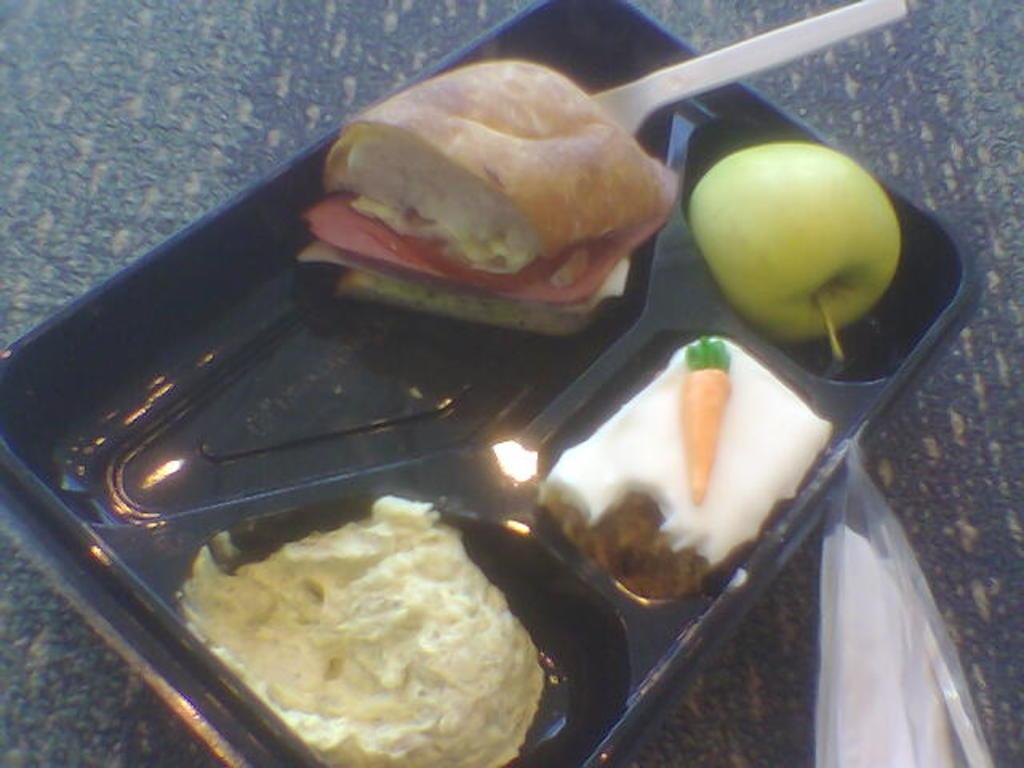What is on the plate that is visible in the image? The plate contains food items. What type of fruit is on or near the plate? There is a green apple on or near the plate. What utensil is on or near the plate? There is a spoon on or near the plate. What is the cover beside the plate used for? The cover beside the plate is likely used for covering the food to keep it fresh or warm. What type of surface is the plate placed on? The plate is placed on a wooden surface. What type of leather is visible on the plate in the image? There is no leather visible on the plate in the image. Is there a crown on the plate in the image? No, there is no crown on the plate in the image. 